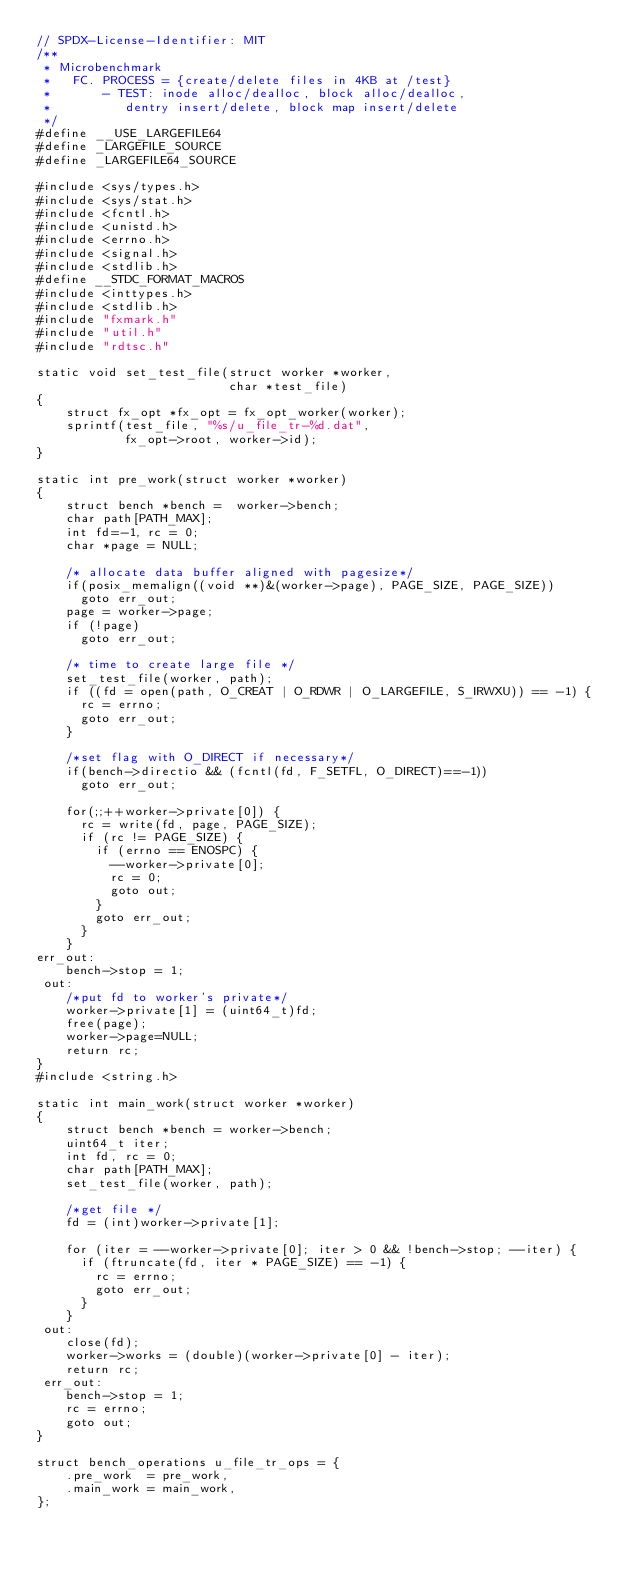<code> <loc_0><loc_0><loc_500><loc_500><_C_>// SPDX-License-Identifier: MIT
/**
 * Microbenchmark
 *   FC. PROCESS = {create/delete files in 4KB at /test}
 *       - TEST: inode alloc/dealloc, block alloc/dealloc,
 *	        dentry insert/delete, block map insert/delete
 */
#define __USE_LARGEFILE64
#define _LARGEFILE_SOURCE
#define _LARGEFILE64_SOURCE

#include <sys/types.h>
#include <sys/stat.h>
#include <fcntl.h>
#include <unistd.h>
#include <errno.h>
#include <signal.h>
#include <stdlib.h>
#define __STDC_FORMAT_MACROS
#include <inttypes.h>
#include <stdlib.h>
#include "fxmark.h"
#include "util.h"
#include "rdtsc.h"

static void set_test_file(struct worker *worker,
                          char *test_file)
{
    struct fx_opt *fx_opt = fx_opt_worker(worker);
    sprintf(test_file, "%s/u_file_tr-%d.dat",
            fx_opt->root, worker->id);
}

static int pre_work(struct worker *worker)
{
    struct bench *bench =  worker->bench;
    char path[PATH_MAX];
    int fd=-1, rc = 0;
    char *page = NULL;

    /* allocate data buffer aligned with pagesize*/                    
    if(posix_memalign((void **)&(worker->page), PAGE_SIZE, PAGE_SIZE)) 
      goto err_out;                                                    
    page = worker->page;                                               
    if (!page)                                                         
      goto err_out;                                                    

    /* time to create large file */
    set_test_file(worker, path);
    if ((fd = open(path, O_CREAT | O_RDWR | O_LARGEFILE, S_IRWXU)) == -1) {
      rc = errno;
      goto err_out;
    }

    /*set flag with O_DIRECT if necessary*/                   
    if(bench->directio && (fcntl(fd, F_SETFL, O_DIRECT)==-1)) 
      goto err_out;                                           

    for(;;++worker->private[0]) {
      rc = write(fd, page, PAGE_SIZE);
      if (rc != PAGE_SIZE) {
        if (errno == ENOSPC) {
          --worker->private[0];
          rc = 0;
          goto out;
        }
        goto err_out;
      }
    }
err_out:
    bench->stop = 1;
 out:
    /*put fd to worker's private*/
    worker->private[1] = (uint64_t)fd;
    free(page);
    worker->page=NULL;
    return rc;
}
#include <string.h>

static int main_work(struct worker *worker)
{
    struct bench *bench = worker->bench;
    uint64_t iter;
    int fd, rc = 0;
    char path[PATH_MAX];
    set_test_file(worker, path);

    /*get file */
    fd = (int)worker->private[1];

    for (iter = --worker->private[0]; iter > 0 && !bench->stop; --iter) {
      if (ftruncate(fd, iter * PAGE_SIZE) == -1) {
        rc = errno;
        goto err_out;
      }
    }
 out:
    close(fd);
    worker->works = (double)(worker->private[0] - iter);
    return rc;
 err_out:
    bench->stop = 1;
    rc = errno;
    goto out;
}

struct bench_operations u_file_tr_ops = {
    .pre_work  = pre_work,
    .main_work = main_work,
};
</code> 